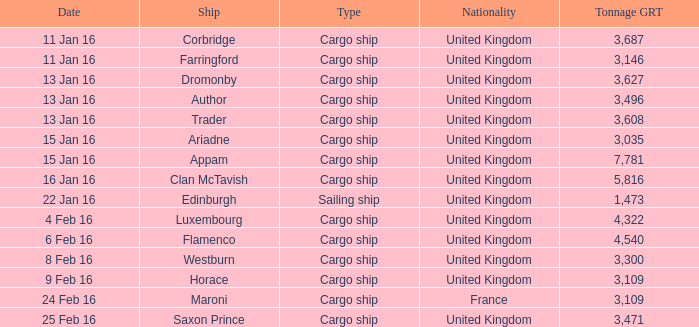What is the total tonnage grt of the cargo ship(s) sunk or captured on 4 feb 16? 1.0. 